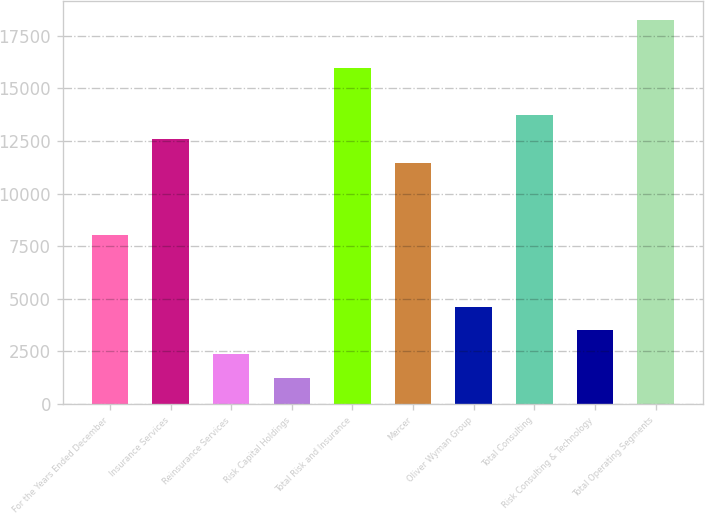Convert chart. <chart><loc_0><loc_0><loc_500><loc_500><bar_chart><fcel>For the Years Ended December<fcel>Insurance Services<fcel>Reinsurance Services<fcel>Risk Capital Holdings<fcel>Total Risk and Insurance<fcel>Mercer<fcel>Oliver Wyman Group<fcel>Total Consulting<fcel>Risk Consulting & Technology<fcel>Total Operating Segments<nl><fcel>8039<fcel>12579<fcel>2364<fcel>1229<fcel>15984<fcel>11444<fcel>4634<fcel>13714<fcel>3499<fcel>18254<nl></chart> 